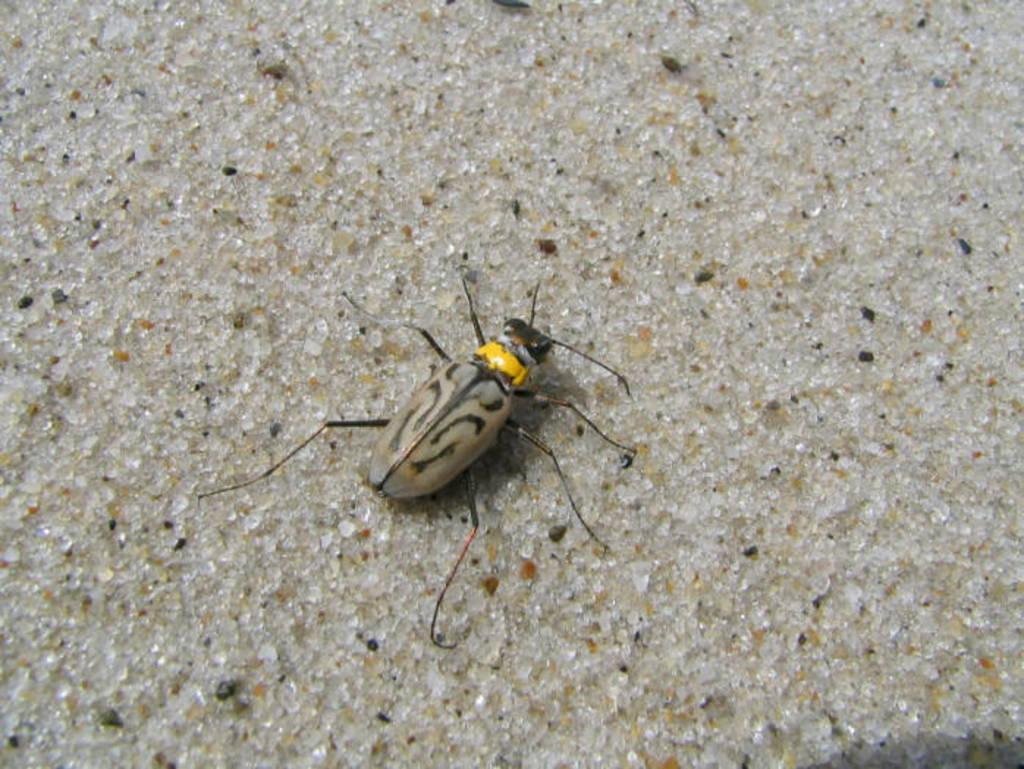What type of creature can be seen in the image? There is an insect in the image. Where is the insect located in the image? The insect is on the floor. What type of hen can be seen in the image? There is no hen present in the image; it features an insect on the floor. What type of ball is being used by the insect in the image? There is no ball present in the image; it features an insect on the floor. 